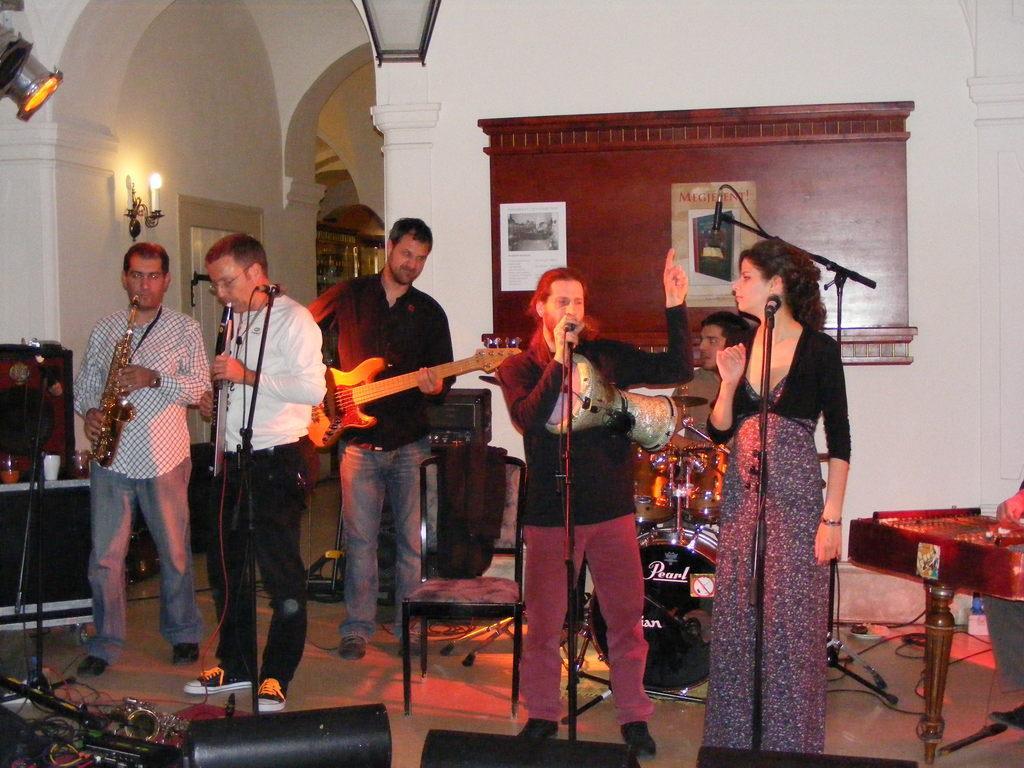Describe this image in one or two sentences. It is a closed room where five people are standing and performing and at right corner one woman is standing in front a microphone and beside her one man is singing and at the left corner two persons are playing instruments and beside them one person is standing and playing guitar and behind him there is a wall with some wooden board on it and one person is sitting and playing drums in the middle of the picture and in front of them there are microphones,speakers and chair and behind them there is another room. 